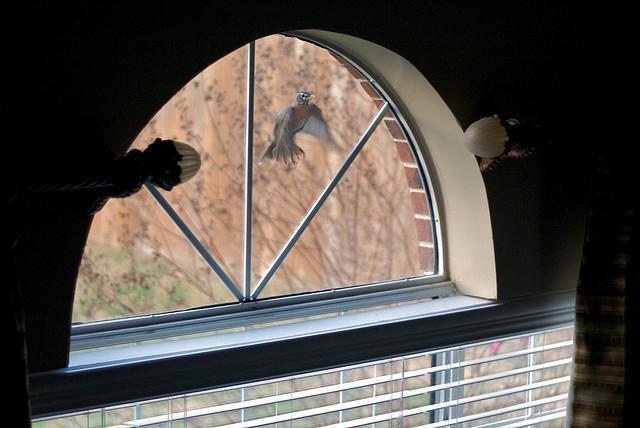How many loading doors does the bus have?
Give a very brief answer. 0. 